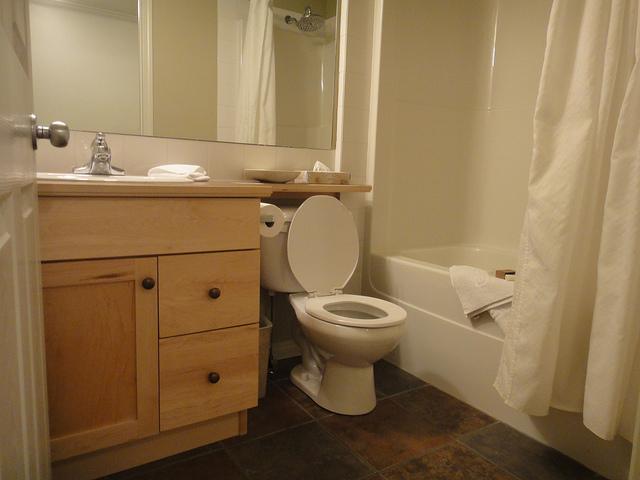What color are the towels?
Write a very short answer. White. What color is the cabinet?
Be succinct. Brown. Where is the bathroom mirror?
Concise answer only. Wall. Is the photographer reflected in the mirror?
Give a very brief answer. No. 